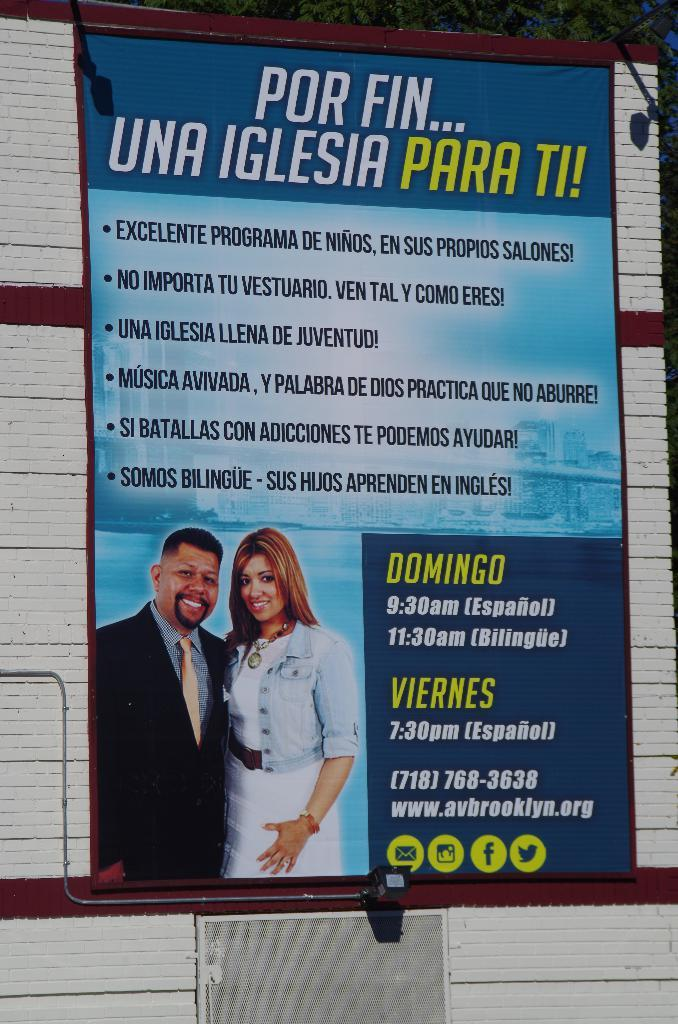What is the main subject in the center of the image? There is a banner in the center of the image. What can be found on the banner? There is text written on the banner, and it has an image of a man and a woman smiling. How many spiders are crawling on the banner in the image? There are no spiders present on the banner in the image. 